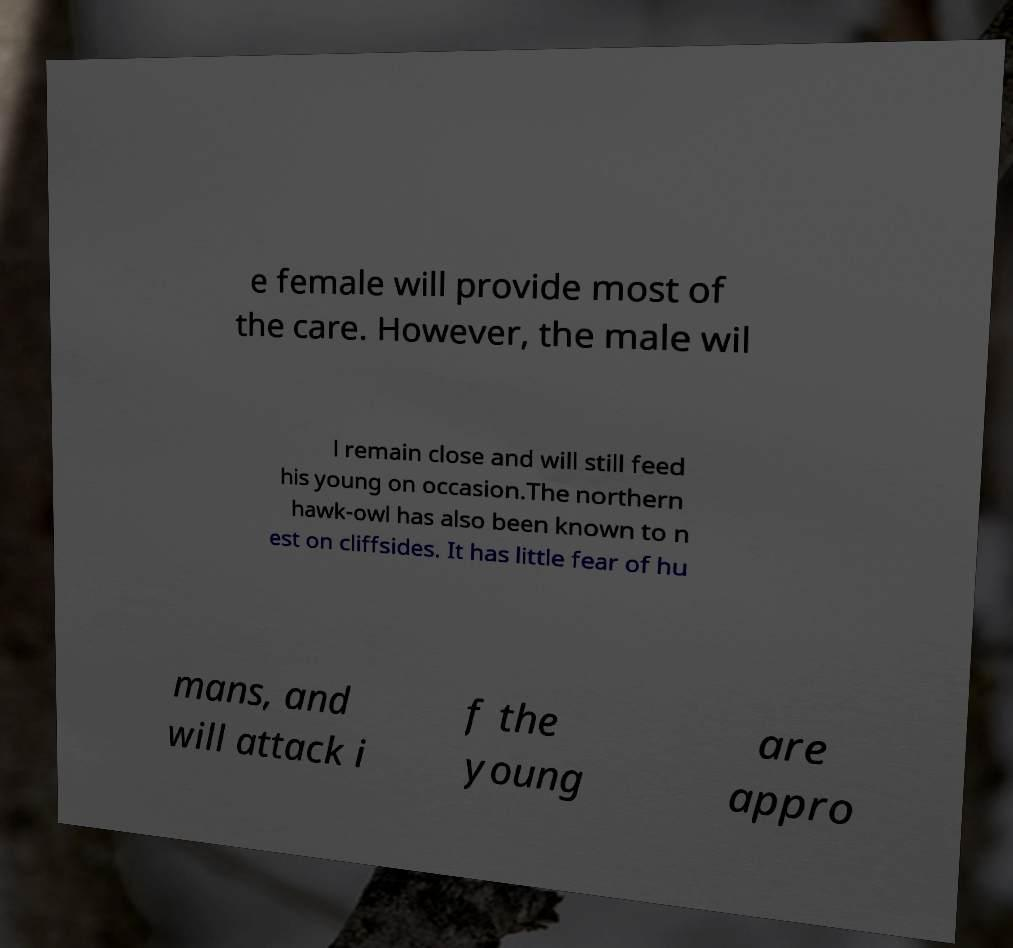For documentation purposes, I need the text within this image transcribed. Could you provide that? e female will provide most of the care. However, the male wil l remain close and will still feed his young on occasion.The northern hawk-owl has also been known to n est on cliffsides. It has little fear of hu mans, and will attack i f the young are appro 